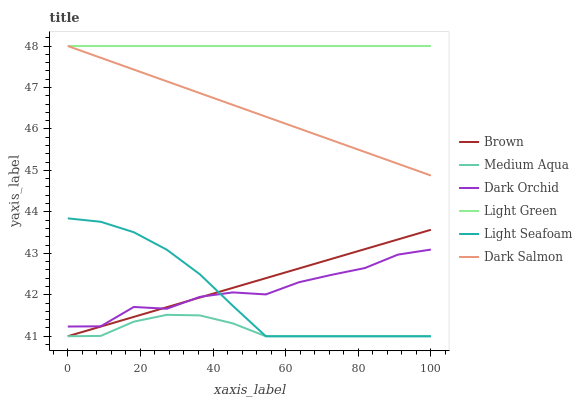Does Medium Aqua have the minimum area under the curve?
Answer yes or no. Yes. Does Light Green have the maximum area under the curve?
Answer yes or no. Yes. Does Dark Salmon have the minimum area under the curve?
Answer yes or no. No. Does Dark Salmon have the maximum area under the curve?
Answer yes or no. No. Is Light Green the smoothest?
Answer yes or no. Yes. Is Dark Orchid the roughest?
Answer yes or no. Yes. Is Dark Salmon the smoothest?
Answer yes or no. No. Is Dark Salmon the roughest?
Answer yes or no. No. Does Brown have the lowest value?
Answer yes or no. Yes. Does Dark Salmon have the lowest value?
Answer yes or no. No. Does Light Green have the highest value?
Answer yes or no. Yes. Does Dark Orchid have the highest value?
Answer yes or no. No. Is Medium Aqua less than Dark Salmon?
Answer yes or no. Yes. Is Light Green greater than Brown?
Answer yes or no. Yes. Does Medium Aqua intersect Brown?
Answer yes or no. Yes. Is Medium Aqua less than Brown?
Answer yes or no. No. Is Medium Aqua greater than Brown?
Answer yes or no. No. Does Medium Aqua intersect Dark Salmon?
Answer yes or no. No. 